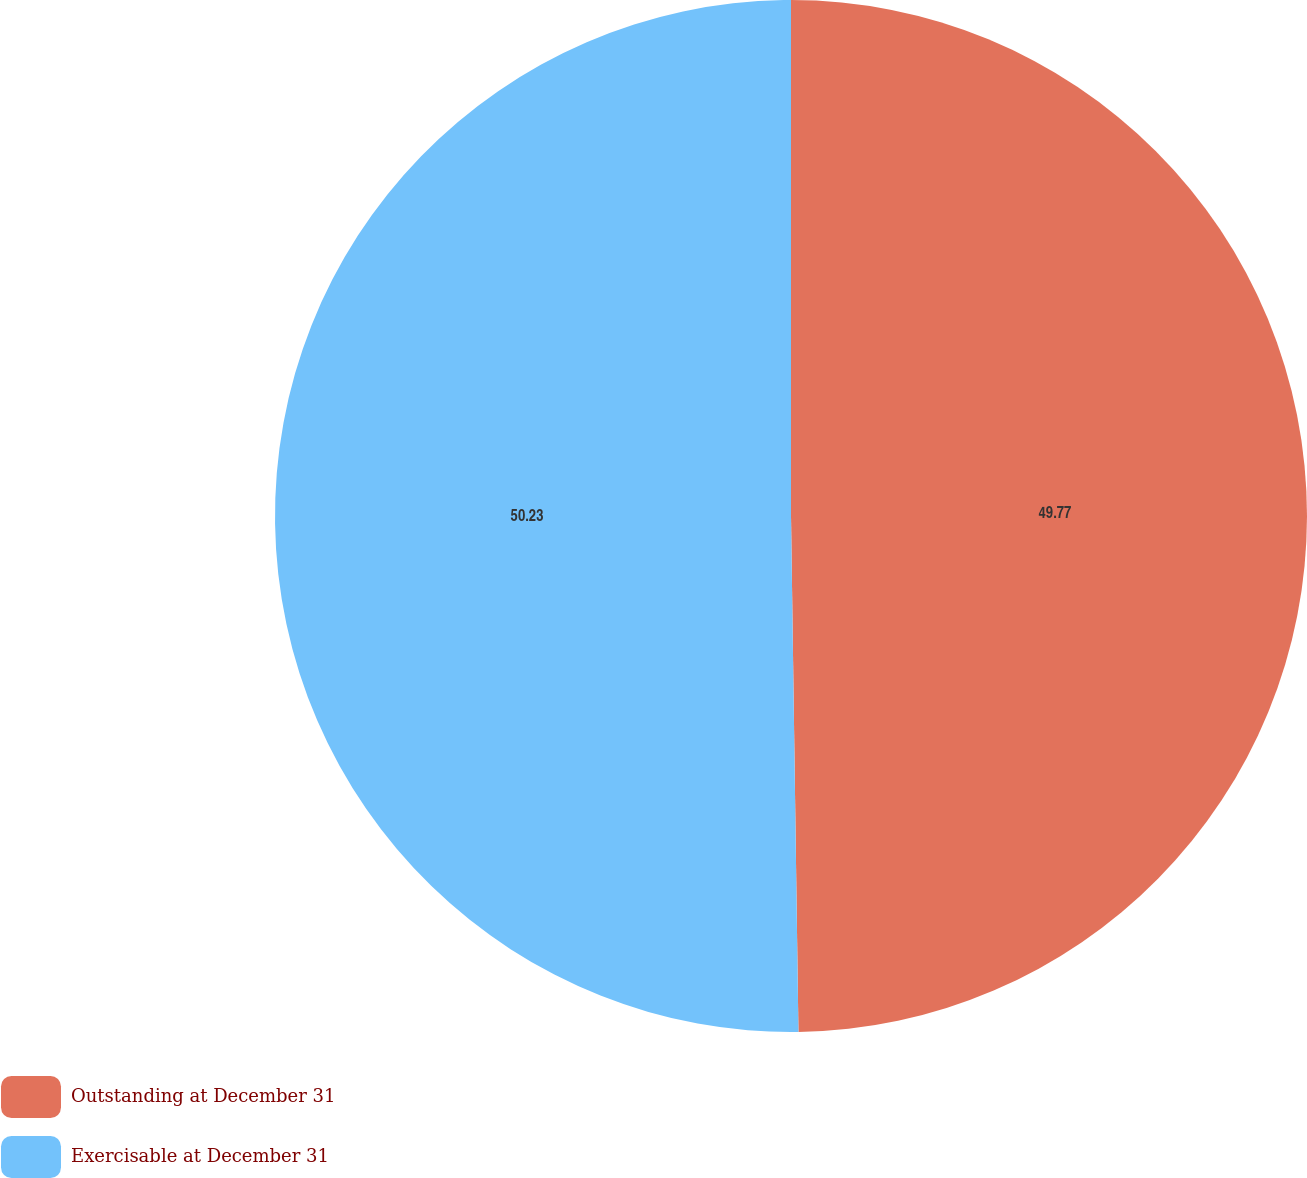<chart> <loc_0><loc_0><loc_500><loc_500><pie_chart><fcel>Outstanding at December 31<fcel>Exercisable at December 31<nl><fcel>49.77%<fcel>50.23%<nl></chart> 